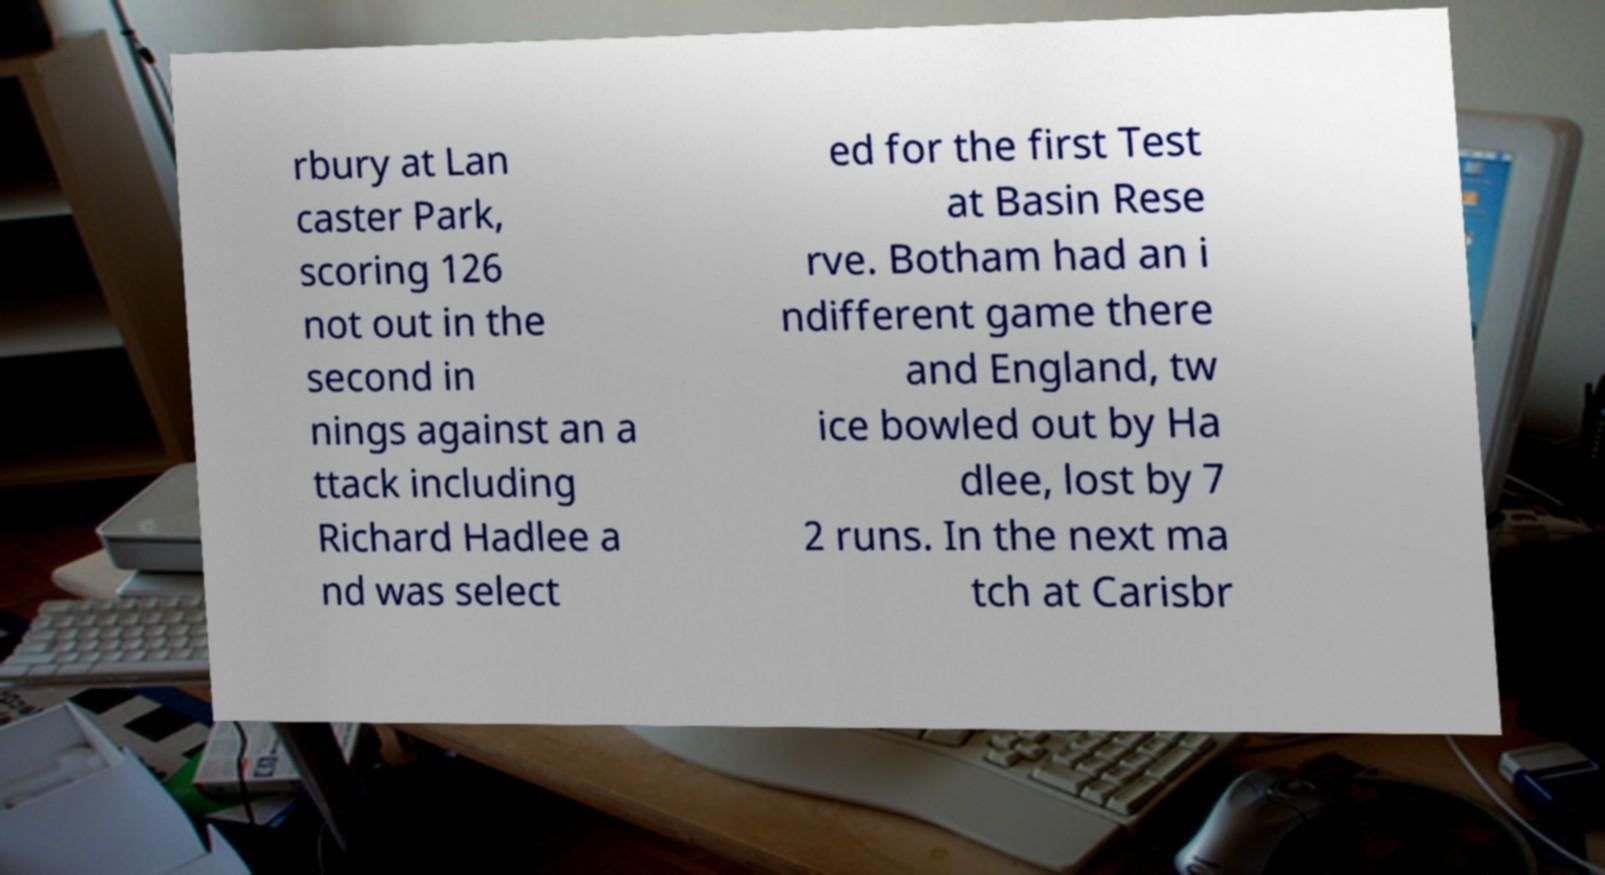Could you assist in decoding the text presented in this image and type it out clearly? rbury at Lan caster Park, scoring 126 not out in the second in nings against an a ttack including Richard Hadlee a nd was select ed for the first Test at Basin Rese rve. Botham had an i ndifferent game there and England, tw ice bowled out by Ha dlee, lost by 7 2 runs. In the next ma tch at Carisbr 